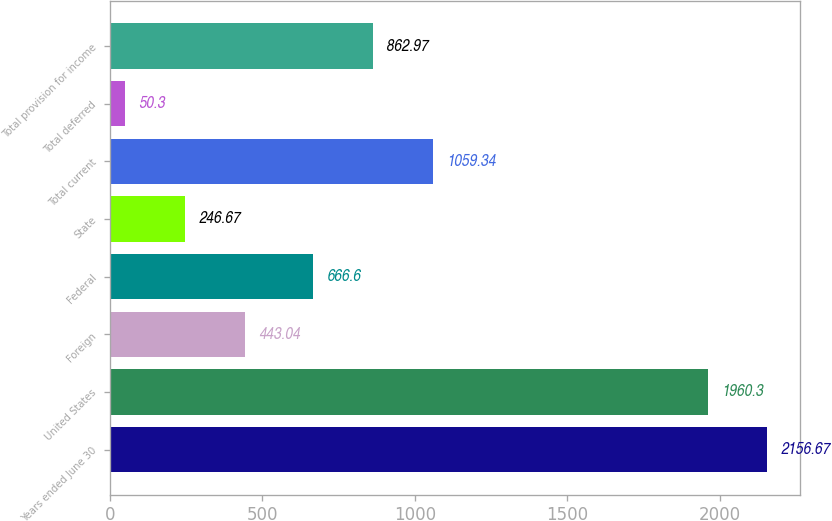Convert chart. <chart><loc_0><loc_0><loc_500><loc_500><bar_chart><fcel>Years ended June 30<fcel>United States<fcel>Foreign<fcel>Federal<fcel>State<fcel>Total current<fcel>Total deferred<fcel>Total provision for income<nl><fcel>2156.67<fcel>1960.3<fcel>443.04<fcel>666.6<fcel>246.67<fcel>1059.34<fcel>50.3<fcel>862.97<nl></chart> 